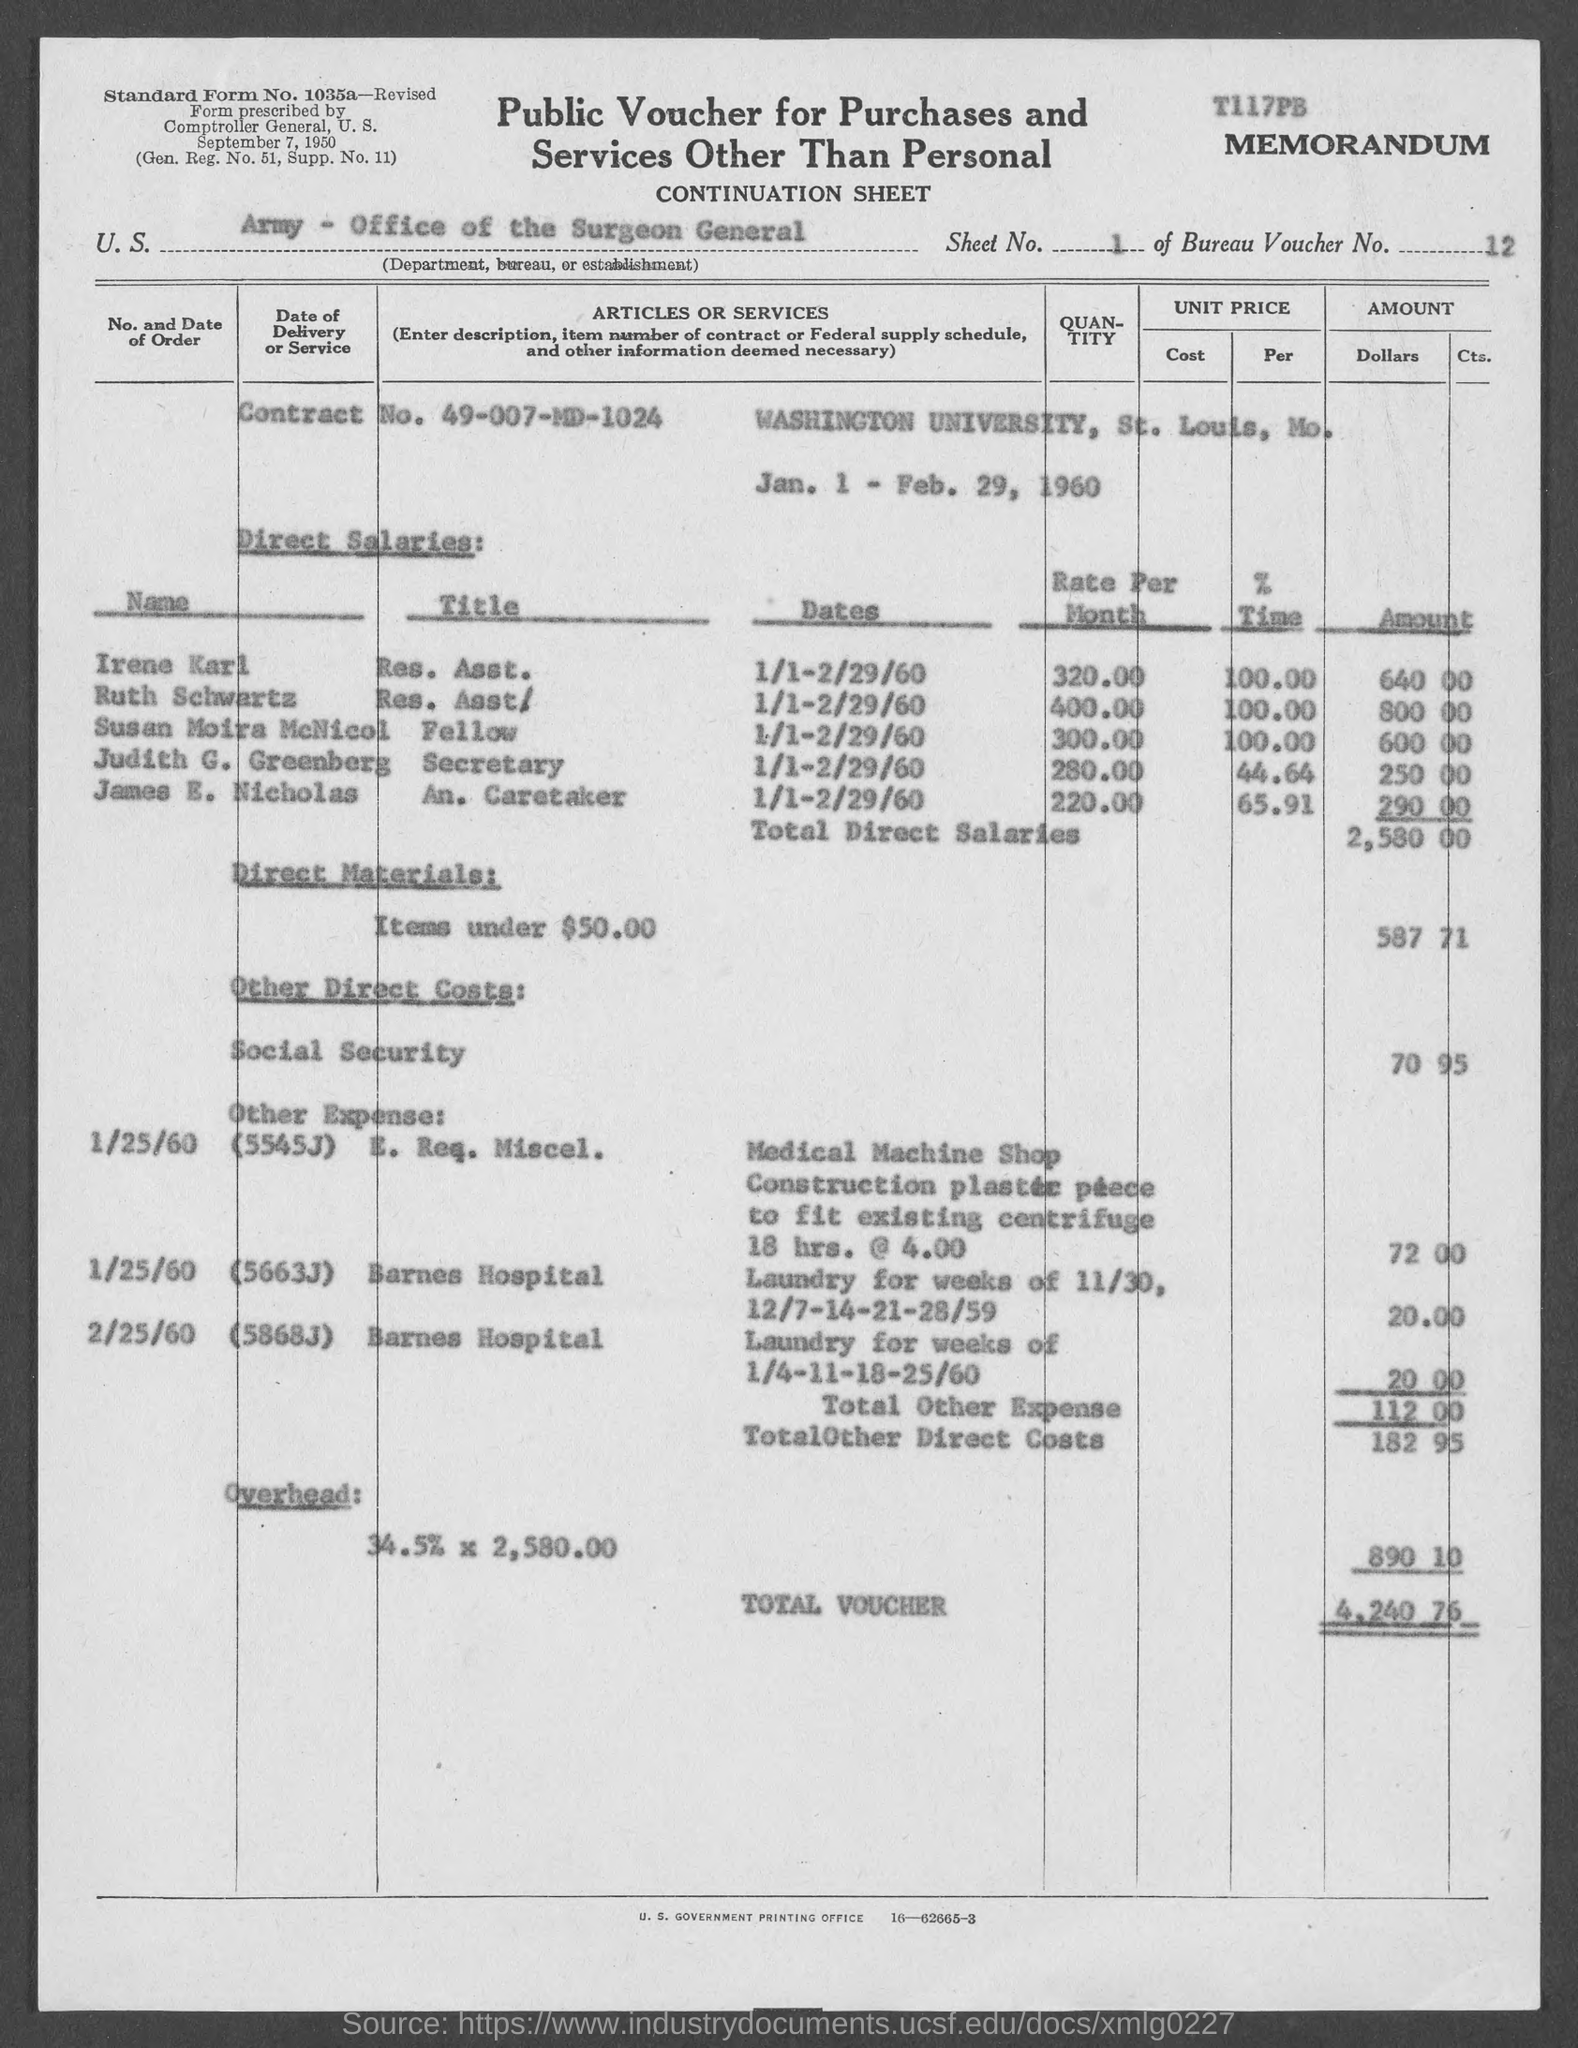Point out several critical features in this image. The Contract No. is 49-007-MD-1024. The Bureau Voucher Number is "12..". The direct salaries amount for James E. Nicholas is $290.00. The overhead amount is 890.10. The direct salaries amount for Susan Moira McNicol is $600.00. 